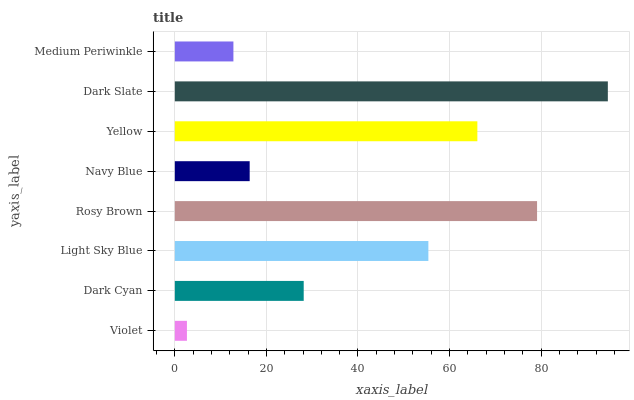Is Violet the minimum?
Answer yes or no. Yes. Is Dark Slate the maximum?
Answer yes or no. Yes. Is Dark Cyan the minimum?
Answer yes or no. No. Is Dark Cyan the maximum?
Answer yes or no. No. Is Dark Cyan greater than Violet?
Answer yes or no. Yes. Is Violet less than Dark Cyan?
Answer yes or no. Yes. Is Violet greater than Dark Cyan?
Answer yes or no. No. Is Dark Cyan less than Violet?
Answer yes or no. No. Is Light Sky Blue the high median?
Answer yes or no. Yes. Is Dark Cyan the low median?
Answer yes or no. Yes. Is Navy Blue the high median?
Answer yes or no. No. Is Navy Blue the low median?
Answer yes or no. No. 